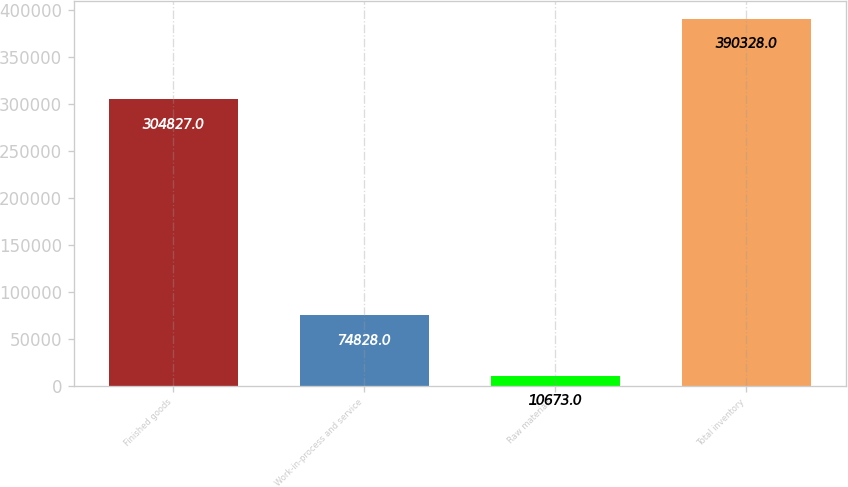Convert chart. <chart><loc_0><loc_0><loc_500><loc_500><bar_chart><fcel>Finished goods<fcel>Work-in-process and service<fcel>Raw materials<fcel>Total inventory<nl><fcel>304827<fcel>74828<fcel>10673<fcel>390328<nl></chart> 